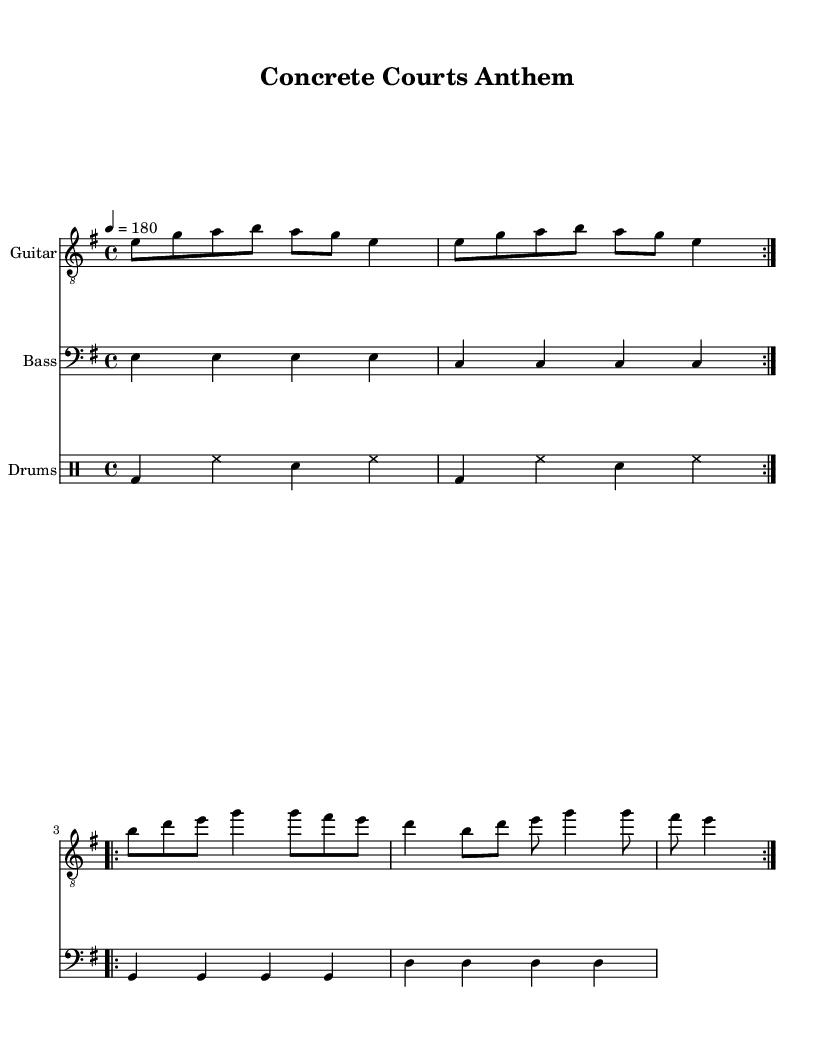What is the key signature of this music? The key signature is E minor, which has one sharp (F#) and is indicated at the beginning of the staff.
Answer: E minor What is the time signature of this piece? The time signature is 4/4, meaning there are four beats in each measure and a quarter note gets one beat. This is denoted at the beginning of the score.
Answer: 4/4 What is the tempo marking indicated for the piece? The tempo marking is indicated as 180 beats per minute (BPM), which provides the speed at which the music should be played. This is shown right before the musical notation begins.
Answer: 180 How many volta repeats are present in the guitar part? There are two volta repeats indicated in the score, as noted by the "repeat volta 2" markings. This means the section will be played twice before moving on.
Answer: 2 Which musical form does the chorus reflect? The chorus reflects a repetitive form typical in punk rock, as shown by the structure of the repeated guitar riffs and the chorus section, which is characteristic of punk music's simplicity and energy.
Answer: Repetitive What type of rhythm pattern is primarily used in the drums? The rhythm pattern used in the drums is a standard rock beat, consisting mainly of bass and snare combinations with hi-hat accents, which is a classic element of punk drumming.
Answer: Standard rock beat What instruments are featured in this piece? The instruments featured in this piece are Guitar, Bass, and Drums, as indicated by the different staves labeled in the score.
Answer: Guitar, Bass, Drums 